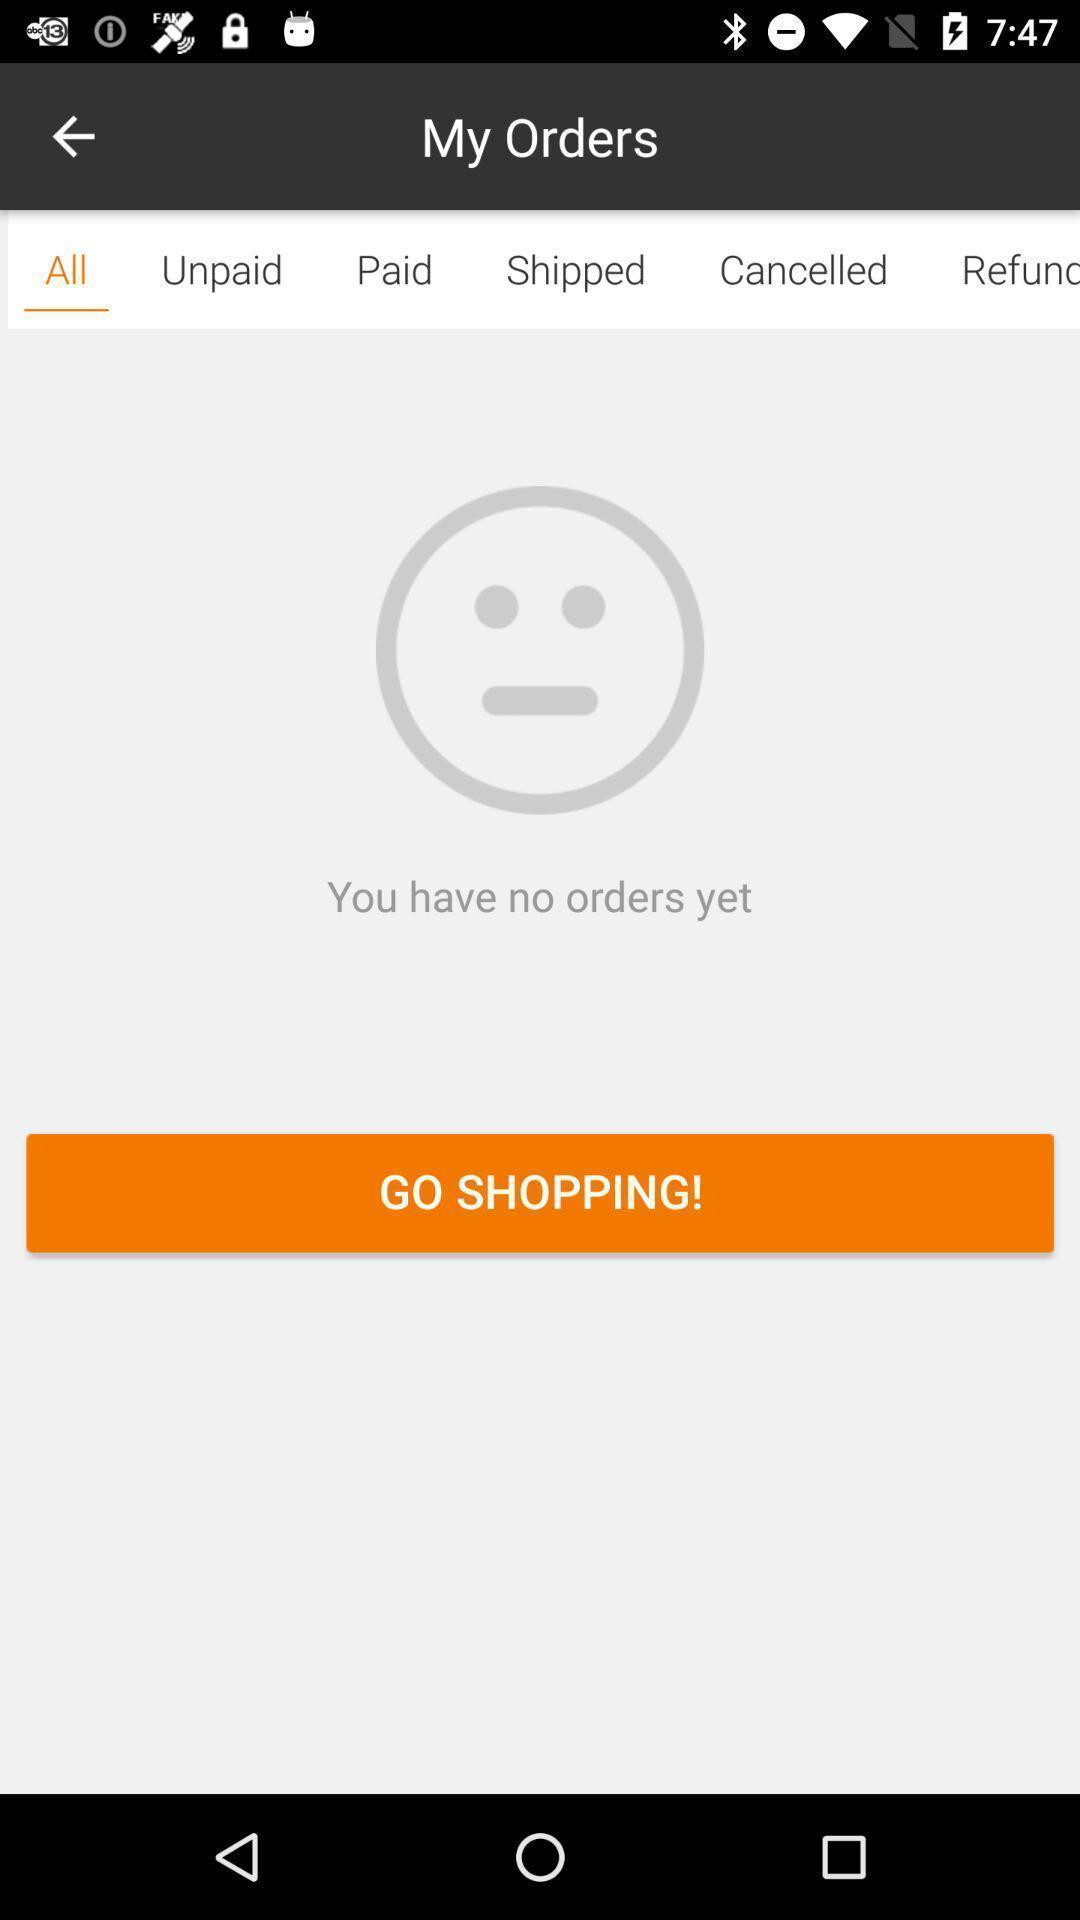Describe the key features of this screenshot. Starting page. 